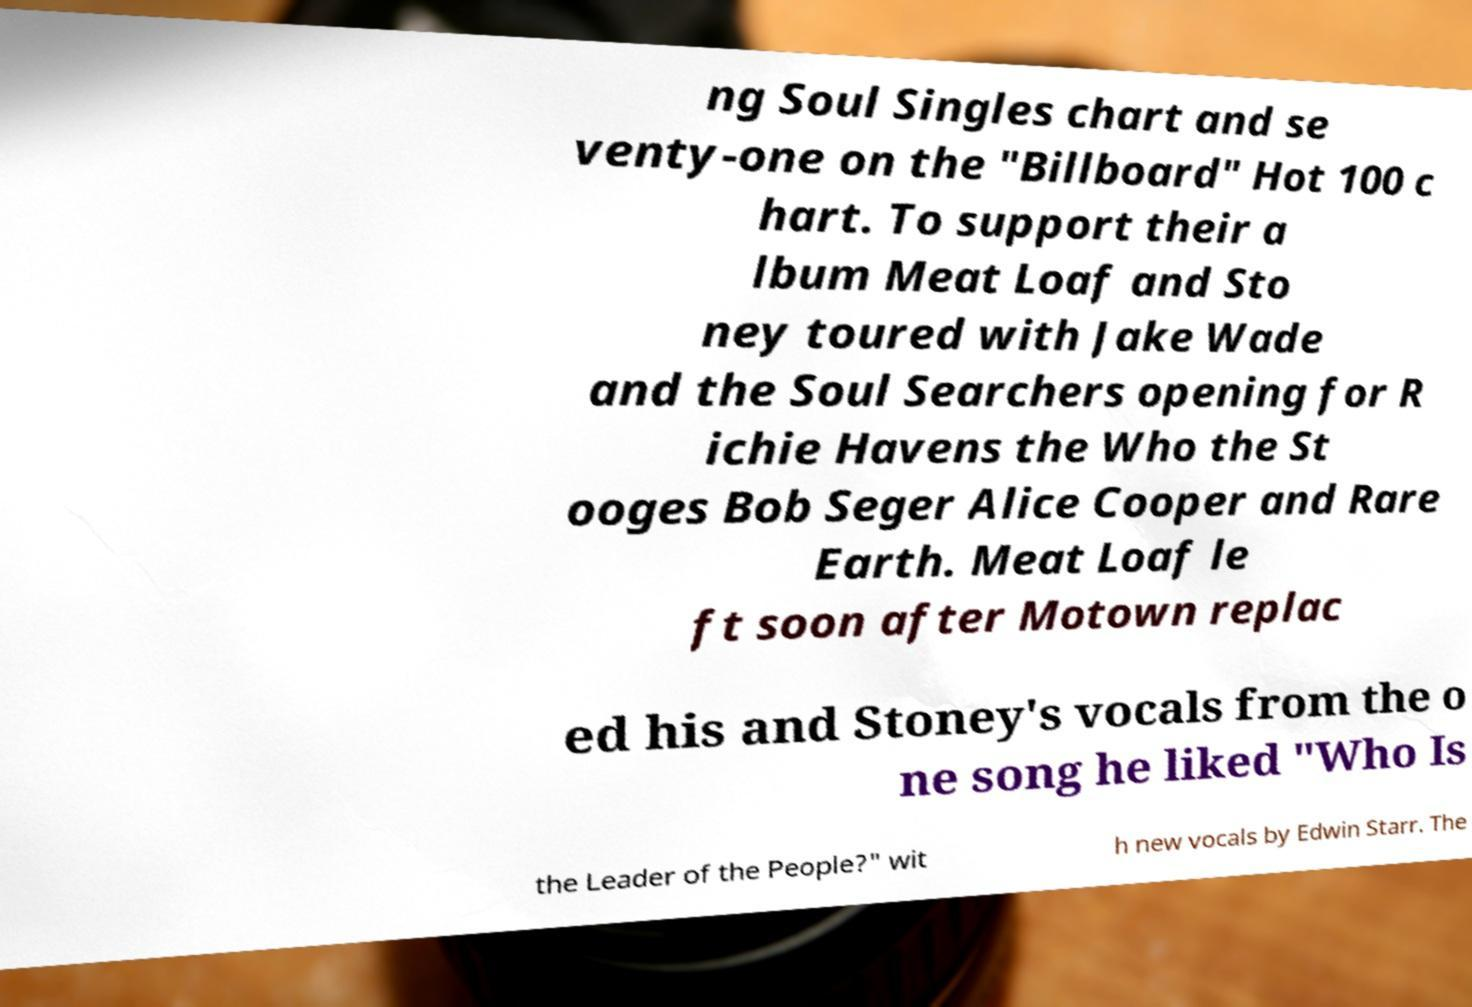There's text embedded in this image that I need extracted. Can you transcribe it verbatim? ng Soul Singles chart and se venty-one on the "Billboard" Hot 100 c hart. To support their a lbum Meat Loaf and Sto ney toured with Jake Wade and the Soul Searchers opening for R ichie Havens the Who the St ooges Bob Seger Alice Cooper and Rare Earth. Meat Loaf le ft soon after Motown replac ed his and Stoney's vocals from the o ne song he liked "Who Is the Leader of the People?" wit h new vocals by Edwin Starr. The 